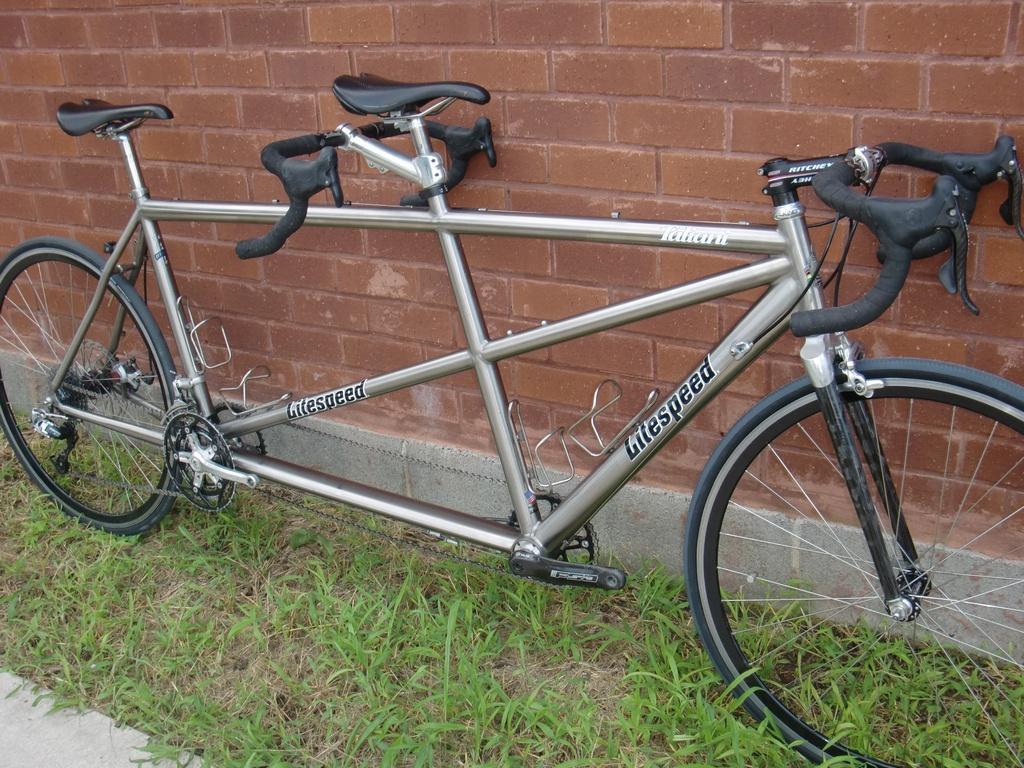Could you give a brief overview of what you see in this image? In this image I can see a vehicle which is in ash and black color. I can see two seats,green grass and wall is in brown color. 